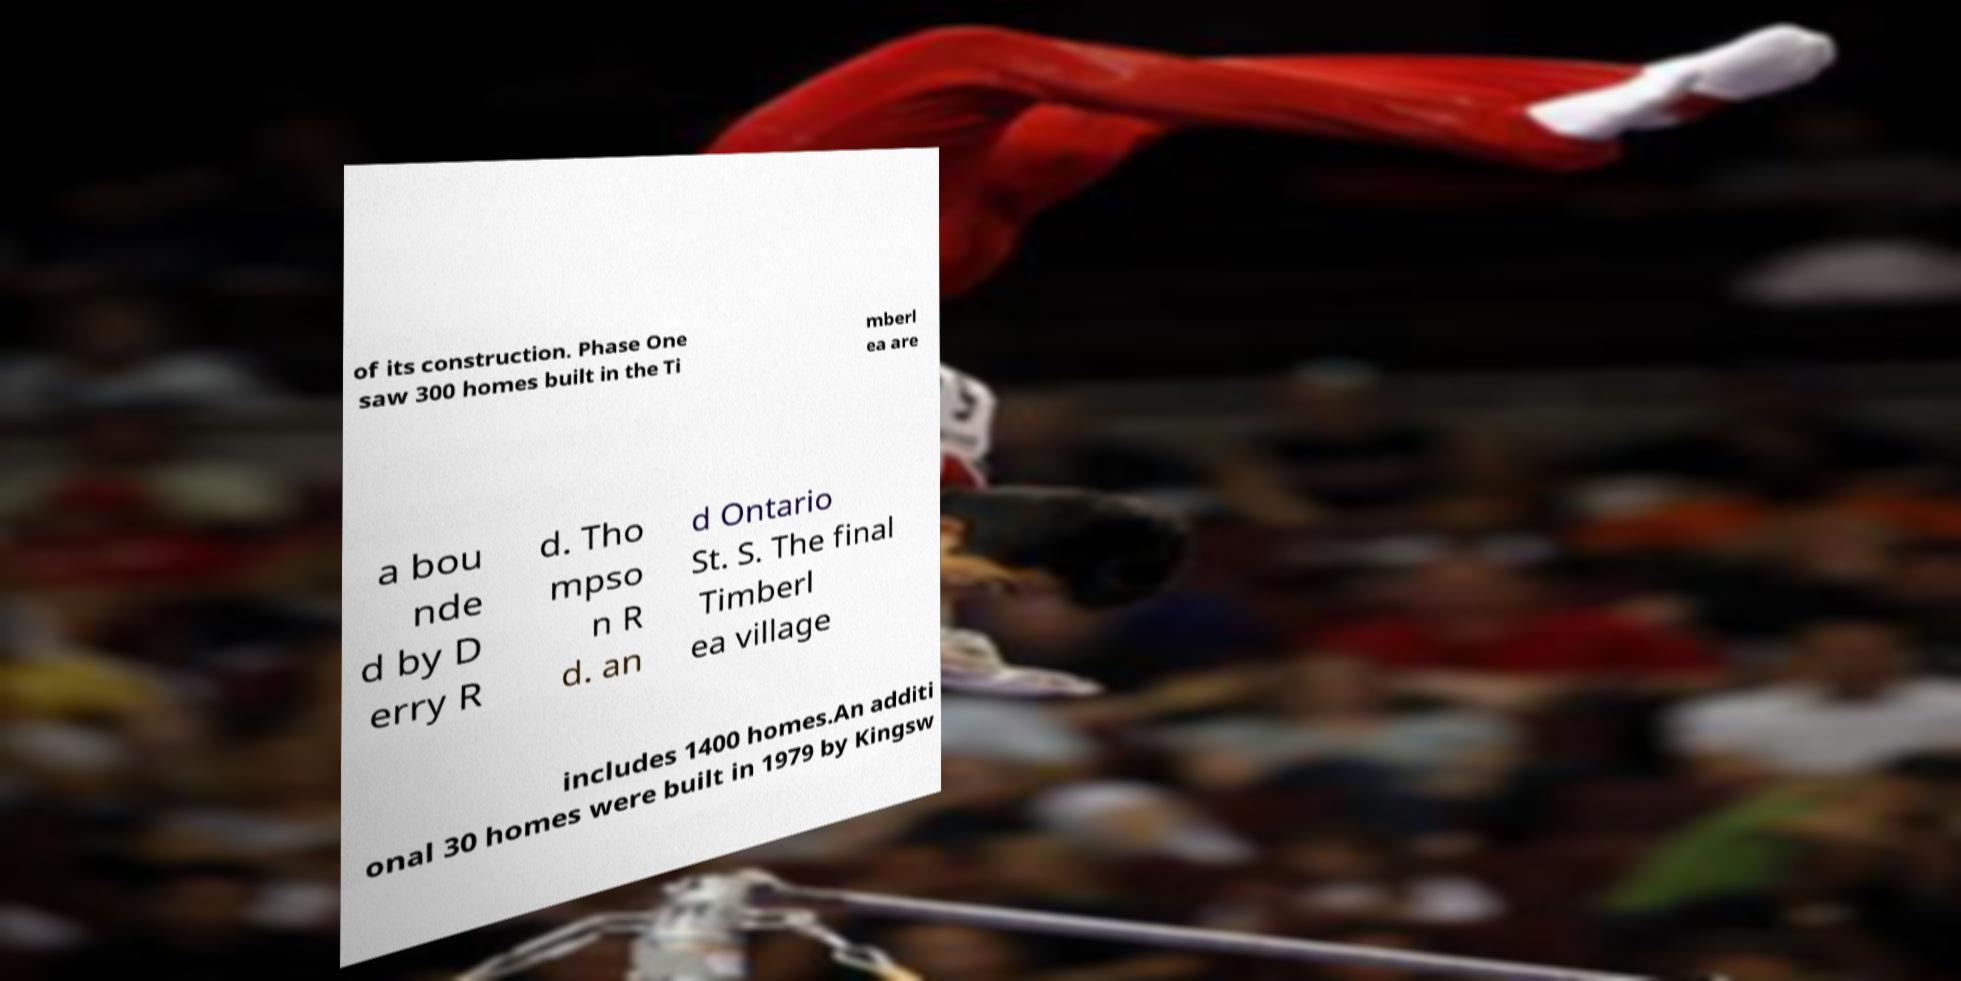Could you assist in decoding the text presented in this image and type it out clearly? of its construction. Phase One saw 300 homes built in the Ti mberl ea are a bou nde d by D erry R d. Tho mpso n R d. an d Ontario St. S. The final Timberl ea village includes 1400 homes.An additi onal 30 homes were built in 1979 by Kingsw 